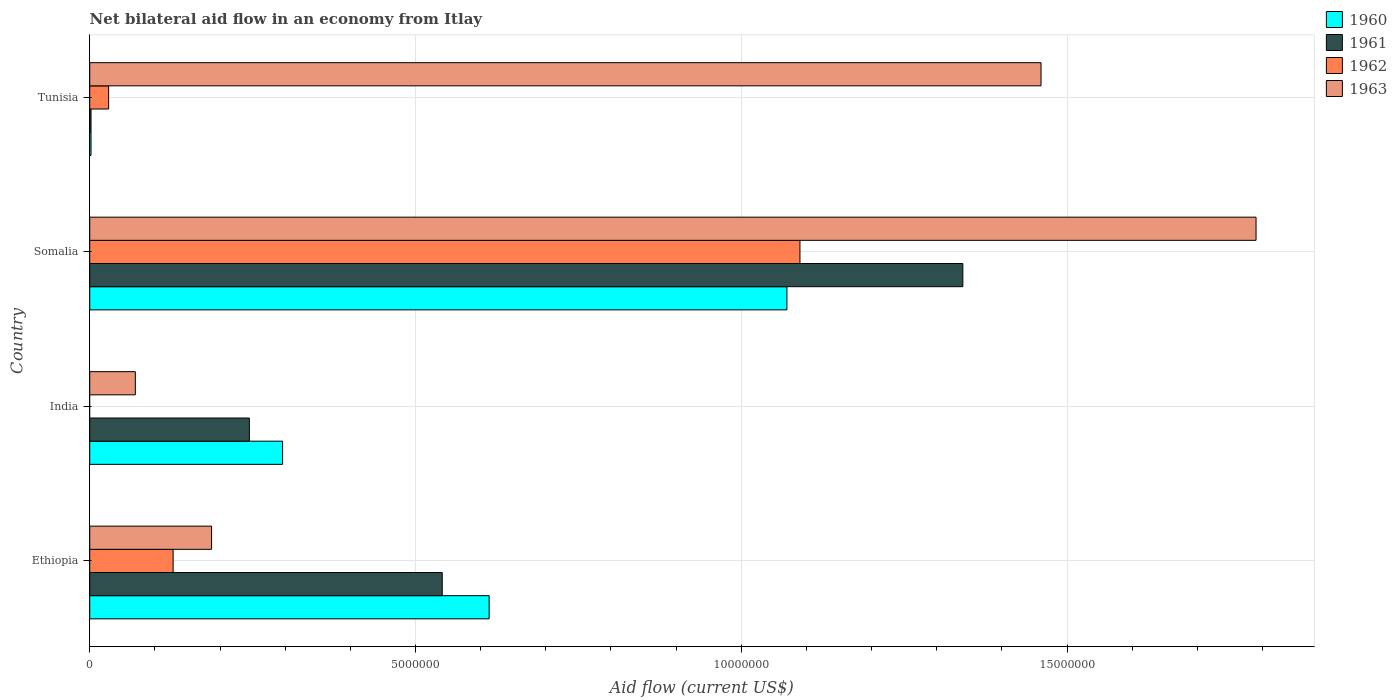How many different coloured bars are there?
Give a very brief answer. 4. Are the number of bars on each tick of the Y-axis equal?
Your answer should be compact. No. What is the label of the 1st group of bars from the top?
Keep it short and to the point. Tunisia. What is the net bilateral aid flow in 1961 in Ethiopia?
Provide a short and direct response. 5.41e+06. Across all countries, what is the maximum net bilateral aid flow in 1963?
Provide a succinct answer. 1.79e+07. Across all countries, what is the minimum net bilateral aid flow in 1960?
Provide a succinct answer. 2.00e+04. In which country was the net bilateral aid flow in 1961 maximum?
Make the answer very short. Somalia. What is the total net bilateral aid flow in 1961 in the graph?
Your answer should be compact. 2.13e+07. What is the difference between the net bilateral aid flow in 1961 in Ethiopia and that in India?
Make the answer very short. 2.96e+06. What is the difference between the net bilateral aid flow in 1962 in Tunisia and the net bilateral aid flow in 1961 in India?
Your answer should be compact. -2.16e+06. What is the average net bilateral aid flow in 1961 per country?
Provide a short and direct response. 5.32e+06. What is the ratio of the net bilateral aid flow in 1960 in Ethiopia to that in Somalia?
Offer a terse response. 0.57. Is the difference between the net bilateral aid flow in 1960 in India and Somalia greater than the difference between the net bilateral aid flow in 1961 in India and Somalia?
Your answer should be compact. Yes. What is the difference between the highest and the second highest net bilateral aid flow in 1962?
Provide a short and direct response. 9.62e+06. What is the difference between the highest and the lowest net bilateral aid flow in 1963?
Give a very brief answer. 1.72e+07. In how many countries, is the net bilateral aid flow in 1962 greater than the average net bilateral aid flow in 1962 taken over all countries?
Ensure brevity in your answer.  1. Is it the case that in every country, the sum of the net bilateral aid flow in 1960 and net bilateral aid flow in 1963 is greater than the sum of net bilateral aid flow in 1961 and net bilateral aid flow in 1962?
Provide a short and direct response. No. How many bars are there?
Offer a terse response. 15. How many countries are there in the graph?
Offer a very short reply. 4. What is the difference between two consecutive major ticks on the X-axis?
Your answer should be very brief. 5.00e+06. Does the graph contain grids?
Ensure brevity in your answer.  Yes. Where does the legend appear in the graph?
Provide a short and direct response. Top right. What is the title of the graph?
Your response must be concise. Net bilateral aid flow in an economy from Itlay. Does "1978" appear as one of the legend labels in the graph?
Ensure brevity in your answer.  No. What is the label or title of the Y-axis?
Your answer should be compact. Country. What is the Aid flow (current US$) of 1960 in Ethiopia?
Make the answer very short. 6.13e+06. What is the Aid flow (current US$) in 1961 in Ethiopia?
Ensure brevity in your answer.  5.41e+06. What is the Aid flow (current US$) of 1962 in Ethiopia?
Give a very brief answer. 1.28e+06. What is the Aid flow (current US$) in 1963 in Ethiopia?
Your answer should be compact. 1.87e+06. What is the Aid flow (current US$) of 1960 in India?
Make the answer very short. 2.96e+06. What is the Aid flow (current US$) in 1961 in India?
Your response must be concise. 2.45e+06. What is the Aid flow (current US$) in 1963 in India?
Your response must be concise. 7.00e+05. What is the Aid flow (current US$) in 1960 in Somalia?
Your answer should be very brief. 1.07e+07. What is the Aid flow (current US$) in 1961 in Somalia?
Provide a succinct answer. 1.34e+07. What is the Aid flow (current US$) of 1962 in Somalia?
Make the answer very short. 1.09e+07. What is the Aid flow (current US$) in 1963 in Somalia?
Provide a short and direct response. 1.79e+07. What is the Aid flow (current US$) of 1960 in Tunisia?
Give a very brief answer. 2.00e+04. What is the Aid flow (current US$) in 1962 in Tunisia?
Make the answer very short. 2.90e+05. What is the Aid flow (current US$) in 1963 in Tunisia?
Your answer should be compact. 1.46e+07. Across all countries, what is the maximum Aid flow (current US$) of 1960?
Give a very brief answer. 1.07e+07. Across all countries, what is the maximum Aid flow (current US$) of 1961?
Your answer should be compact. 1.34e+07. Across all countries, what is the maximum Aid flow (current US$) in 1962?
Provide a succinct answer. 1.09e+07. Across all countries, what is the maximum Aid flow (current US$) in 1963?
Ensure brevity in your answer.  1.79e+07. Across all countries, what is the minimum Aid flow (current US$) in 1960?
Offer a terse response. 2.00e+04. What is the total Aid flow (current US$) in 1960 in the graph?
Offer a very short reply. 1.98e+07. What is the total Aid flow (current US$) of 1961 in the graph?
Provide a short and direct response. 2.13e+07. What is the total Aid flow (current US$) of 1962 in the graph?
Make the answer very short. 1.25e+07. What is the total Aid flow (current US$) of 1963 in the graph?
Offer a very short reply. 3.51e+07. What is the difference between the Aid flow (current US$) of 1960 in Ethiopia and that in India?
Ensure brevity in your answer.  3.17e+06. What is the difference between the Aid flow (current US$) of 1961 in Ethiopia and that in India?
Provide a succinct answer. 2.96e+06. What is the difference between the Aid flow (current US$) in 1963 in Ethiopia and that in India?
Your answer should be very brief. 1.17e+06. What is the difference between the Aid flow (current US$) in 1960 in Ethiopia and that in Somalia?
Provide a succinct answer. -4.57e+06. What is the difference between the Aid flow (current US$) in 1961 in Ethiopia and that in Somalia?
Give a very brief answer. -7.99e+06. What is the difference between the Aid flow (current US$) of 1962 in Ethiopia and that in Somalia?
Provide a succinct answer. -9.62e+06. What is the difference between the Aid flow (current US$) of 1963 in Ethiopia and that in Somalia?
Give a very brief answer. -1.60e+07. What is the difference between the Aid flow (current US$) of 1960 in Ethiopia and that in Tunisia?
Keep it short and to the point. 6.11e+06. What is the difference between the Aid flow (current US$) in 1961 in Ethiopia and that in Tunisia?
Your answer should be compact. 5.39e+06. What is the difference between the Aid flow (current US$) in 1962 in Ethiopia and that in Tunisia?
Give a very brief answer. 9.90e+05. What is the difference between the Aid flow (current US$) of 1963 in Ethiopia and that in Tunisia?
Offer a terse response. -1.27e+07. What is the difference between the Aid flow (current US$) of 1960 in India and that in Somalia?
Your answer should be compact. -7.74e+06. What is the difference between the Aid flow (current US$) in 1961 in India and that in Somalia?
Your response must be concise. -1.10e+07. What is the difference between the Aid flow (current US$) of 1963 in India and that in Somalia?
Ensure brevity in your answer.  -1.72e+07. What is the difference between the Aid flow (current US$) in 1960 in India and that in Tunisia?
Keep it short and to the point. 2.94e+06. What is the difference between the Aid flow (current US$) of 1961 in India and that in Tunisia?
Your answer should be compact. 2.43e+06. What is the difference between the Aid flow (current US$) of 1963 in India and that in Tunisia?
Your answer should be compact. -1.39e+07. What is the difference between the Aid flow (current US$) in 1960 in Somalia and that in Tunisia?
Provide a short and direct response. 1.07e+07. What is the difference between the Aid flow (current US$) in 1961 in Somalia and that in Tunisia?
Ensure brevity in your answer.  1.34e+07. What is the difference between the Aid flow (current US$) in 1962 in Somalia and that in Tunisia?
Provide a short and direct response. 1.06e+07. What is the difference between the Aid flow (current US$) of 1963 in Somalia and that in Tunisia?
Offer a terse response. 3.30e+06. What is the difference between the Aid flow (current US$) in 1960 in Ethiopia and the Aid flow (current US$) in 1961 in India?
Make the answer very short. 3.68e+06. What is the difference between the Aid flow (current US$) in 1960 in Ethiopia and the Aid flow (current US$) in 1963 in India?
Provide a short and direct response. 5.43e+06. What is the difference between the Aid flow (current US$) of 1961 in Ethiopia and the Aid flow (current US$) of 1963 in India?
Ensure brevity in your answer.  4.71e+06. What is the difference between the Aid flow (current US$) in 1962 in Ethiopia and the Aid flow (current US$) in 1963 in India?
Offer a very short reply. 5.80e+05. What is the difference between the Aid flow (current US$) of 1960 in Ethiopia and the Aid flow (current US$) of 1961 in Somalia?
Ensure brevity in your answer.  -7.27e+06. What is the difference between the Aid flow (current US$) in 1960 in Ethiopia and the Aid flow (current US$) in 1962 in Somalia?
Offer a very short reply. -4.77e+06. What is the difference between the Aid flow (current US$) of 1960 in Ethiopia and the Aid flow (current US$) of 1963 in Somalia?
Make the answer very short. -1.18e+07. What is the difference between the Aid flow (current US$) in 1961 in Ethiopia and the Aid flow (current US$) in 1962 in Somalia?
Provide a short and direct response. -5.49e+06. What is the difference between the Aid flow (current US$) of 1961 in Ethiopia and the Aid flow (current US$) of 1963 in Somalia?
Give a very brief answer. -1.25e+07. What is the difference between the Aid flow (current US$) in 1962 in Ethiopia and the Aid flow (current US$) in 1963 in Somalia?
Your answer should be compact. -1.66e+07. What is the difference between the Aid flow (current US$) in 1960 in Ethiopia and the Aid flow (current US$) in 1961 in Tunisia?
Give a very brief answer. 6.11e+06. What is the difference between the Aid flow (current US$) in 1960 in Ethiopia and the Aid flow (current US$) in 1962 in Tunisia?
Provide a succinct answer. 5.84e+06. What is the difference between the Aid flow (current US$) of 1960 in Ethiopia and the Aid flow (current US$) of 1963 in Tunisia?
Ensure brevity in your answer.  -8.47e+06. What is the difference between the Aid flow (current US$) in 1961 in Ethiopia and the Aid flow (current US$) in 1962 in Tunisia?
Your response must be concise. 5.12e+06. What is the difference between the Aid flow (current US$) of 1961 in Ethiopia and the Aid flow (current US$) of 1963 in Tunisia?
Offer a very short reply. -9.19e+06. What is the difference between the Aid flow (current US$) in 1962 in Ethiopia and the Aid flow (current US$) in 1963 in Tunisia?
Give a very brief answer. -1.33e+07. What is the difference between the Aid flow (current US$) of 1960 in India and the Aid flow (current US$) of 1961 in Somalia?
Give a very brief answer. -1.04e+07. What is the difference between the Aid flow (current US$) of 1960 in India and the Aid flow (current US$) of 1962 in Somalia?
Your answer should be compact. -7.94e+06. What is the difference between the Aid flow (current US$) in 1960 in India and the Aid flow (current US$) in 1963 in Somalia?
Ensure brevity in your answer.  -1.49e+07. What is the difference between the Aid flow (current US$) in 1961 in India and the Aid flow (current US$) in 1962 in Somalia?
Keep it short and to the point. -8.45e+06. What is the difference between the Aid flow (current US$) of 1961 in India and the Aid flow (current US$) of 1963 in Somalia?
Offer a terse response. -1.54e+07. What is the difference between the Aid flow (current US$) of 1960 in India and the Aid flow (current US$) of 1961 in Tunisia?
Your answer should be compact. 2.94e+06. What is the difference between the Aid flow (current US$) of 1960 in India and the Aid flow (current US$) of 1962 in Tunisia?
Ensure brevity in your answer.  2.67e+06. What is the difference between the Aid flow (current US$) in 1960 in India and the Aid flow (current US$) in 1963 in Tunisia?
Ensure brevity in your answer.  -1.16e+07. What is the difference between the Aid flow (current US$) of 1961 in India and the Aid flow (current US$) of 1962 in Tunisia?
Ensure brevity in your answer.  2.16e+06. What is the difference between the Aid flow (current US$) of 1961 in India and the Aid flow (current US$) of 1963 in Tunisia?
Keep it short and to the point. -1.22e+07. What is the difference between the Aid flow (current US$) of 1960 in Somalia and the Aid flow (current US$) of 1961 in Tunisia?
Make the answer very short. 1.07e+07. What is the difference between the Aid flow (current US$) in 1960 in Somalia and the Aid flow (current US$) in 1962 in Tunisia?
Offer a terse response. 1.04e+07. What is the difference between the Aid flow (current US$) in 1960 in Somalia and the Aid flow (current US$) in 1963 in Tunisia?
Your response must be concise. -3.90e+06. What is the difference between the Aid flow (current US$) of 1961 in Somalia and the Aid flow (current US$) of 1962 in Tunisia?
Provide a short and direct response. 1.31e+07. What is the difference between the Aid flow (current US$) in 1961 in Somalia and the Aid flow (current US$) in 1963 in Tunisia?
Ensure brevity in your answer.  -1.20e+06. What is the difference between the Aid flow (current US$) of 1962 in Somalia and the Aid flow (current US$) of 1963 in Tunisia?
Provide a short and direct response. -3.70e+06. What is the average Aid flow (current US$) of 1960 per country?
Ensure brevity in your answer.  4.95e+06. What is the average Aid flow (current US$) in 1961 per country?
Offer a very short reply. 5.32e+06. What is the average Aid flow (current US$) of 1962 per country?
Keep it short and to the point. 3.12e+06. What is the average Aid flow (current US$) in 1963 per country?
Your response must be concise. 8.77e+06. What is the difference between the Aid flow (current US$) of 1960 and Aid flow (current US$) of 1961 in Ethiopia?
Provide a short and direct response. 7.20e+05. What is the difference between the Aid flow (current US$) of 1960 and Aid flow (current US$) of 1962 in Ethiopia?
Your answer should be compact. 4.85e+06. What is the difference between the Aid flow (current US$) of 1960 and Aid flow (current US$) of 1963 in Ethiopia?
Make the answer very short. 4.26e+06. What is the difference between the Aid flow (current US$) in 1961 and Aid flow (current US$) in 1962 in Ethiopia?
Offer a very short reply. 4.13e+06. What is the difference between the Aid flow (current US$) in 1961 and Aid flow (current US$) in 1963 in Ethiopia?
Give a very brief answer. 3.54e+06. What is the difference between the Aid flow (current US$) of 1962 and Aid flow (current US$) of 1963 in Ethiopia?
Give a very brief answer. -5.90e+05. What is the difference between the Aid flow (current US$) in 1960 and Aid flow (current US$) in 1961 in India?
Your answer should be compact. 5.10e+05. What is the difference between the Aid flow (current US$) in 1960 and Aid flow (current US$) in 1963 in India?
Your response must be concise. 2.26e+06. What is the difference between the Aid flow (current US$) in 1961 and Aid flow (current US$) in 1963 in India?
Offer a terse response. 1.75e+06. What is the difference between the Aid flow (current US$) in 1960 and Aid flow (current US$) in 1961 in Somalia?
Offer a very short reply. -2.70e+06. What is the difference between the Aid flow (current US$) of 1960 and Aid flow (current US$) of 1963 in Somalia?
Your answer should be compact. -7.20e+06. What is the difference between the Aid flow (current US$) of 1961 and Aid flow (current US$) of 1962 in Somalia?
Offer a terse response. 2.50e+06. What is the difference between the Aid flow (current US$) in 1961 and Aid flow (current US$) in 1963 in Somalia?
Provide a succinct answer. -4.50e+06. What is the difference between the Aid flow (current US$) in 1962 and Aid flow (current US$) in 1963 in Somalia?
Your answer should be very brief. -7.00e+06. What is the difference between the Aid flow (current US$) of 1960 and Aid flow (current US$) of 1961 in Tunisia?
Ensure brevity in your answer.  0. What is the difference between the Aid flow (current US$) in 1960 and Aid flow (current US$) in 1962 in Tunisia?
Offer a very short reply. -2.70e+05. What is the difference between the Aid flow (current US$) in 1960 and Aid flow (current US$) in 1963 in Tunisia?
Keep it short and to the point. -1.46e+07. What is the difference between the Aid flow (current US$) of 1961 and Aid flow (current US$) of 1963 in Tunisia?
Your answer should be very brief. -1.46e+07. What is the difference between the Aid flow (current US$) of 1962 and Aid flow (current US$) of 1963 in Tunisia?
Your response must be concise. -1.43e+07. What is the ratio of the Aid flow (current US$) of 1960 in Ethiopia to that in India?
Keep it short and to the point. 2.07. What is the ratio of the Aid flow (current US$) in 1961 in Ethiopia to that in India?
Offer a very short reply. 2.21. What is the ratio of the Aid flow (current US$) of 1963 in Ethiopia to that in India?
Offer a terse response. 2.67. What is the ratio of the Aid flow (current US$) in 1960 in Ethiopia to that in Somalia?
Keep it short and to the point. 0.57. What is the ratio of the Aid flow (current US$) of 1961 in Ethiopia to that in Somalia?
Make the answer very short. 0.4. What is the ratio of the Aid flow (current US$) of 1962 in Ethiopia to that in Somalia?
Offer a very short reply. 0.12. What is the ratio of the Aid flow (current US$) in 1963 in Ethiopia to that in Somalia?
Your answer should be compact. 0.1. What is the ratio of the Aid flow (current US$) of 1960 in Ethiopia to that in Tunisia?
Give a very brief answer. 306.5. What is the ratio of the Aid flow (current US$) of 1961 in Ethiopia to that in Tunisia?
Your answer should be very brief. 270.5. What is the ratio of the Aid flow (current US$) in 1962 in Ethiopia to that in Tunisia?
Provide a short and direct response. 4.41. What is the ratio of the Aid flow (current US$) in 1963 in Ethiopia to that in Tunisia?
Give a very brief answer. 0.13. What is the ratio of the Aid flow (current US$) in 1960 in India to that in Somalia?
Provide a short and direct response. 0.28. What is the ratio of the Aid flow (current US$) of 1961 in India to that in Somalia?
Your response must be concise. 0.18. What is the ratio of the Aid flow (current US$) of 1963 in India to that in Somalia?
Keep it short and to the point. 0.04. What is the ratio of the Aid flow (current US$) of 1960 in India to that in Tunisia?
Ensure brevity in your answer.  148. What is the ratio of the Aid flow (current US$) of 1961 in India to that in Tunisia?
Your answer should be very brief. 122.5. What is the ratio of the Aid flow (current US$) in 1963 in India to that in Tunisia?
Your answer should be very brief. 0.05. What is the ratio of the Aid flow (current US$) in 1960 in Somalia to that in Tunisia?
Give a very brief answer. 535. What is the ratio of the Aid flow (current US$) of 1961 in Somalia to that in Tunisia?
Your answer should be compact. 670. What is the ratio of the Aid flow (current US$) of 1962 in Somalia to that in Tunisia?
Make the answer very short. 37.59. What is the ratio of the Aid flow (current US$) in 1963 in Somalia to that in Tunisia?
Ensure brevity in your answer.  1.23. What is the difference between the highest and the second highest Aid flow (current US$) of 1960?
Provide a succinct answer. 4.57e+06. What is the difference between the highest and the second highest Aid flow (current US$) of 1961?
Your answer should be compact. 7.99e+06. What is the difference between the highest and the second highest Aid flow (current US$) in 1962?
Offer a terse response. 9.62e+06. What is the difference between the highest and the second highest Aid flow (current US$) of 1963?
Provide a short and direct response. 3.30e+06. What is the difference between the highest and the lowest Aid flow (current US$) of 1960?
Your answer should be very brief. 1.07e+07. What is the difference between the highest and the lowest Aid flow (current US$) in 1961?
Keep it short and to the point. 1.34e+07. What is the difference between the highest and the lowest Aid flow (current US$) of 1962?
Give a very brief answer. 1.09e+07. What is the difference between the highest and the lowest Aid flow (current US$) of 1963?
Your answer should be very brief. 1.72e+07. 